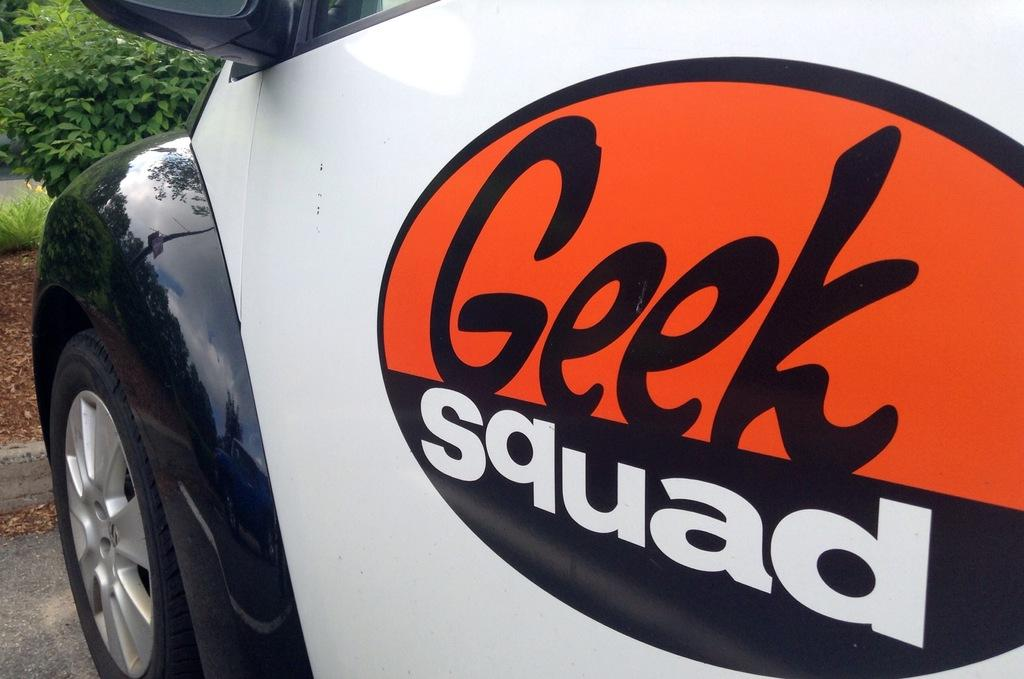What is the main subject of the image? There is a vehicle in the image. Where was the image taken? The image was taken outside. Can you describe any other elements in the image besides the vehicle? There is a plant in the top left corner of the image. What type of bottle is being used to establish a connection in the image? There is no bottle or connection present in the image; it features a vehicle and a plant. 